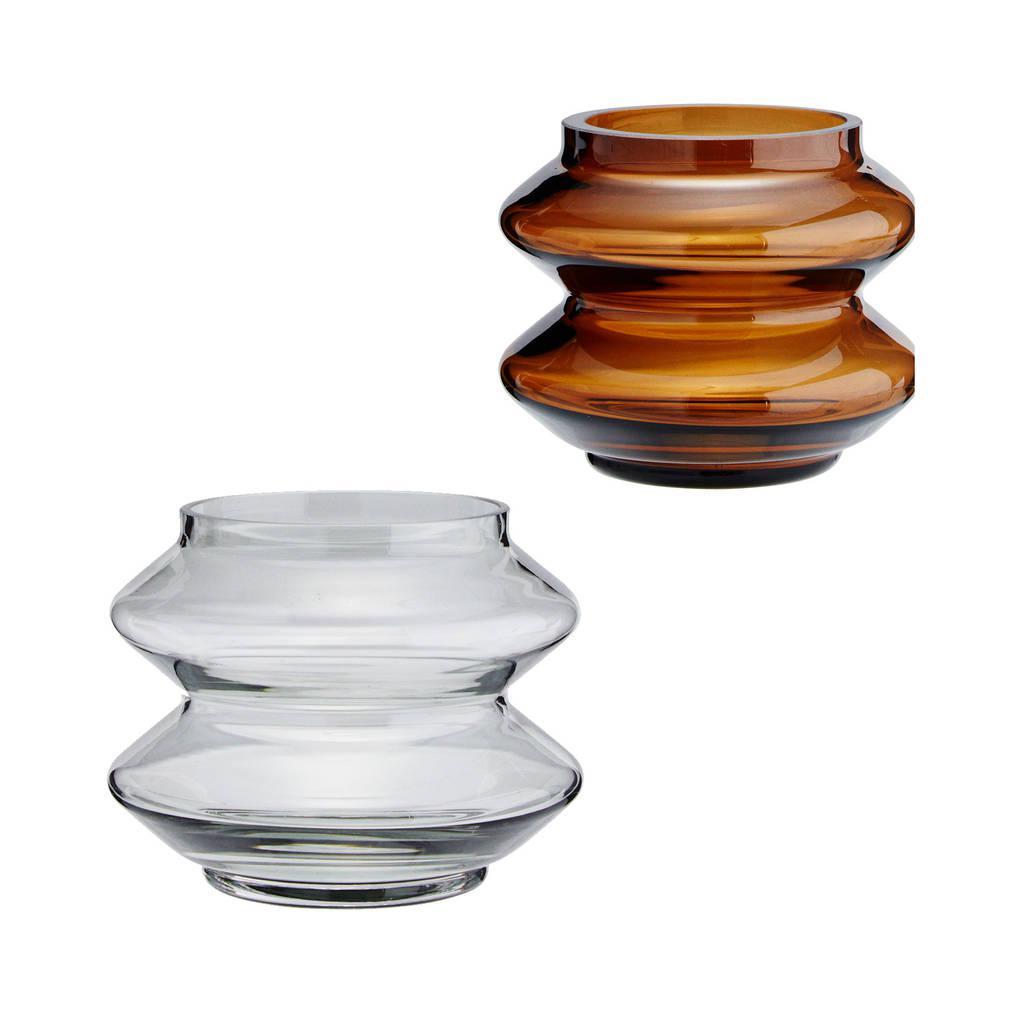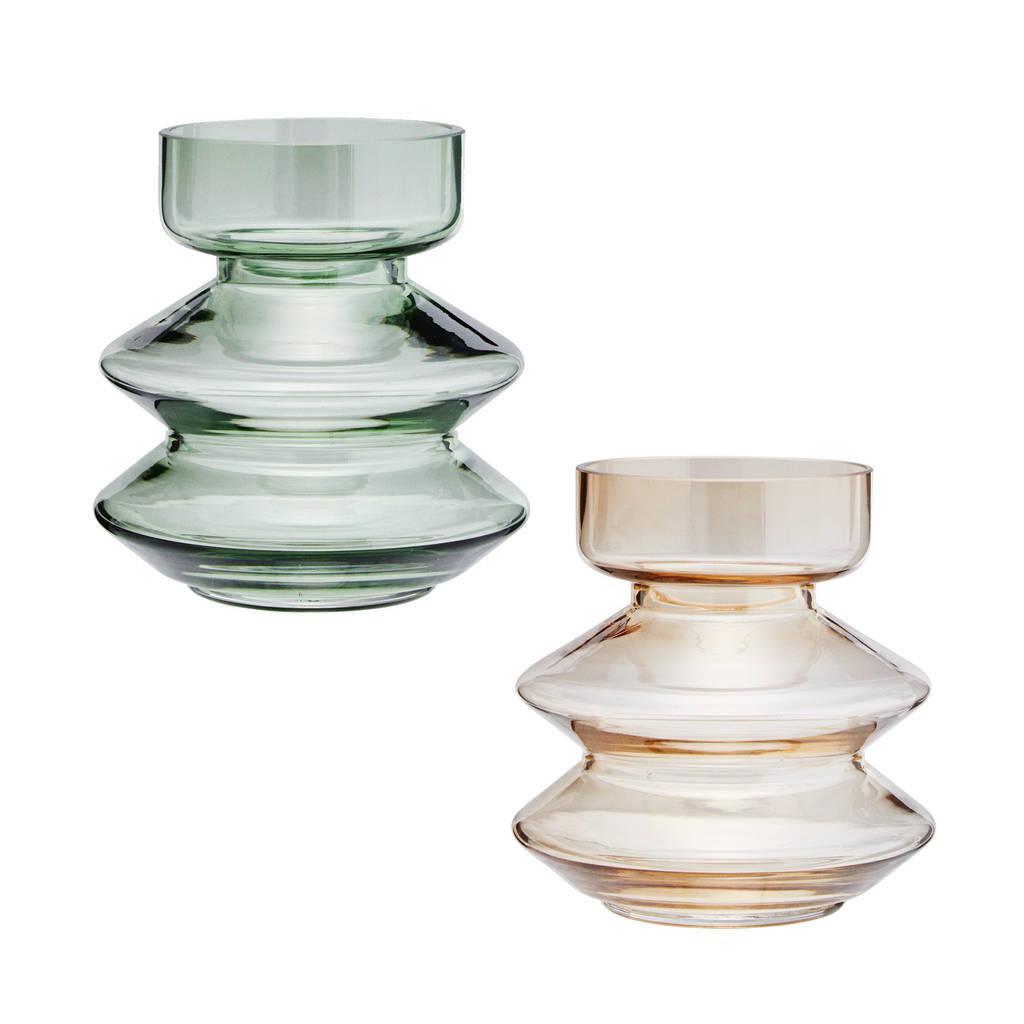The first image is the image on the left, the second image is the image on the right. Assess this claim about the two images: "An image shows a jar with a flower in it.". Correct or not? Answer yes or no. No. The first image is the image on the left, the second image is the image on the right. Evaluate the accuracy of this statement regarding the images: "The number of jars in one image without lids is the same number in the other image with lids.". Is it true? Answer yes or no. Yes. 